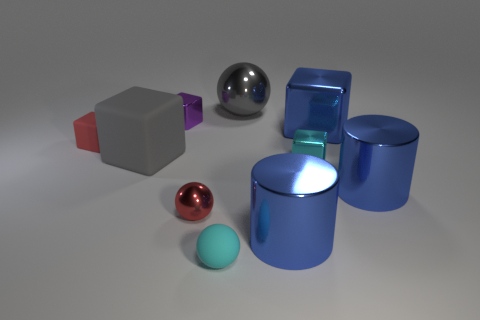Is there a small blue metallic cylinder? no 